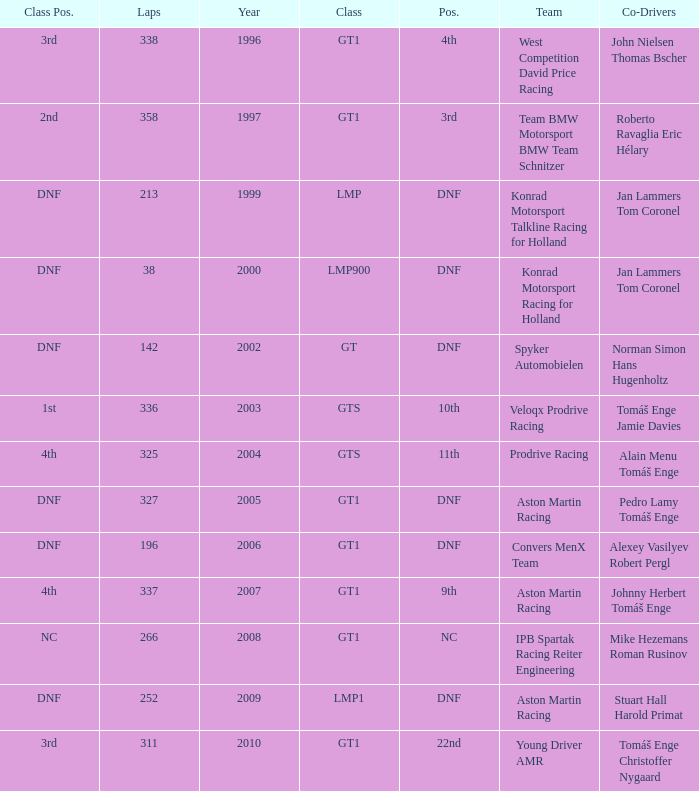What was the position in 1997? 3rd. 